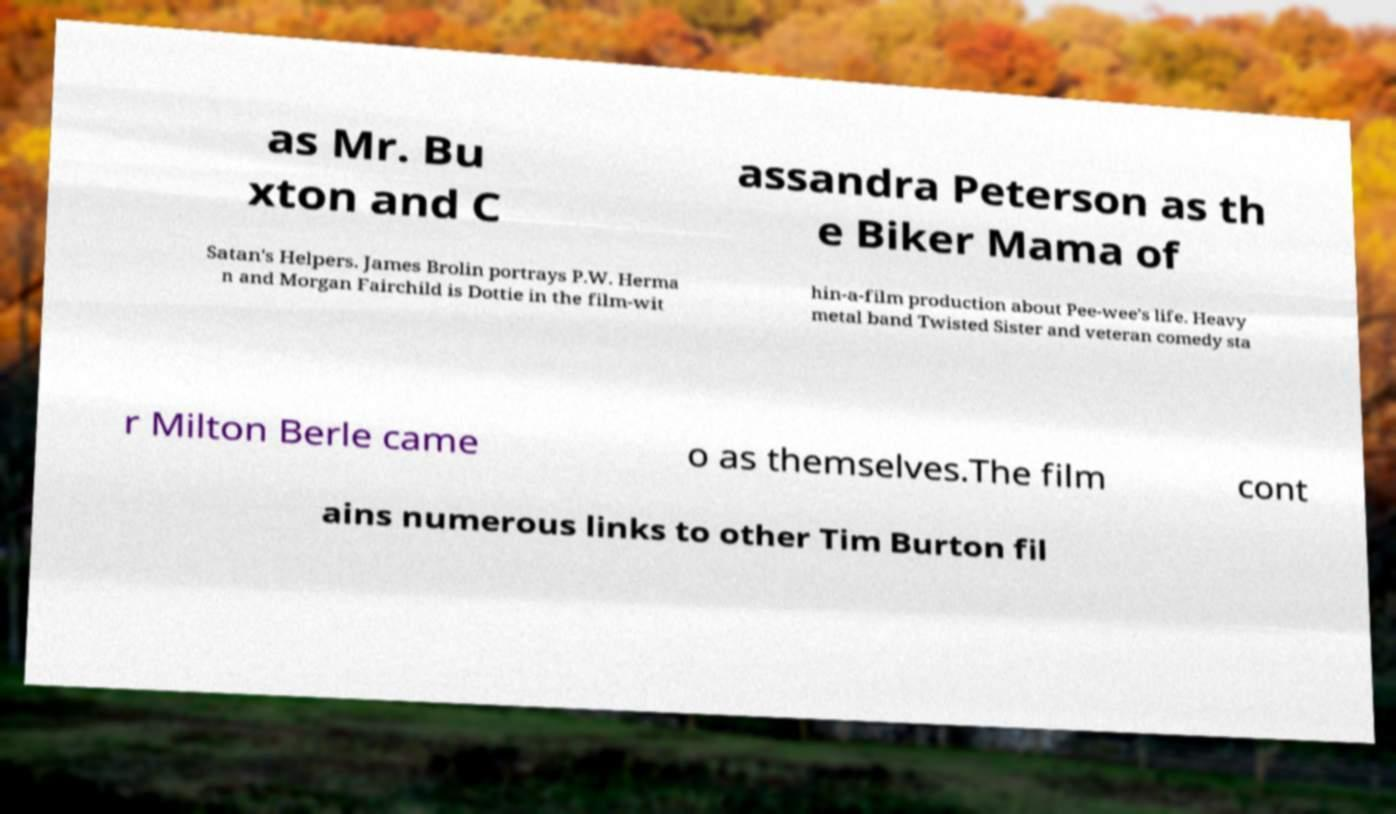Can you accurately transcribe the text from the provided image for me? as Mr. Bu xton and C assandra Peterson as th e Biker Mama of Satan's Helpers. James Brolin portrays P.W. Herma n and Morgan Fairchild is Dottie in the film-wit hin-a-film production about Pee-wee's life. Heavy metal band Twisted Sister and veteran comedy sta r Milton Berle came o as themselves.The film cont ains numerous links to other Tim Burton fil 